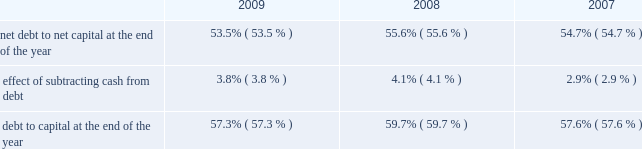Entergy corporation and subsidiaries management's financial discussion and analysis methodology of computing massachusetts state income taxes resulting from legislation passed in the third quarter 2008 , which resulted in an income tax benefit of approximately $ 18.8 million .
These factors were partially offset by : income taxes recorded by entergy power generation , llc , prior to its liquidation , resulting from the redemption payments it received in connection with its investment in entergy nuclear power marketing , llc during the third quarter 2008 , which resulted in an income tax expense of approximately $ 16.1 million ; book and tax differences for utility plant items and state income taxes at the utility operating companies , including the flow-through treatment of the entergy arkansas write-offs discussed above .
The effective income tax rate for 2007 was 30.7% ( 30.7 % ) .
The reduction in the effective income tax rate versus the federal statutory rate of 35% ( 35 % ) in 2007 is primarily due to : a reduction in income tax expense due to a step-up in the tax basis on the indian point 2 non-qualified decommissioning trust fund resulting from restructuring of the trusts , which reduced deferred taxes on the trust fund and reduced current tax expense ; the resolution of tax audit issues involving the 2002-2003 audit cycle ; an adjustment to state income taxes for non-utility nuclear to reflect the effect of a change in the methodology of computing new york state income taxes as required by that state's taxing authority ; book and tax differences related to the allowance for equity funds used during construction ; and the amortization of investment tax credits .
These factors were partially offset by book and tax differences for utility plant items and state income taxes at the utility operating companies .
See note 3 to the financial statements for a reconciliation of the federal statutory rate of 35.0% ( 35.0 % ) to the effective income tax rates , and for additional discussion regarding income taxes .
Liquidity and capital resources this section discusses entergy's capital structure , capital spending plans and other uses of capital , sources of capital , and the cash flow activity presented in the cash flow statement .
Capital structure entergy's capitalization is balanced between equity and debt , as shown in the table .
The decrease in the debt to capital percentage from 2008 to 2009 is primarily the result of an increase in shareholders' equity primarily due to an increase in retained earnings , partially offset by repurchases of common stock , along with a decrease in borrowings under entergy corporation's revolving credit facility .
The increase in the debt to capital percentage from 2007 to 2008 is primarily the result of additional borrowings under entergy corporation's revolving credit facility. .

What is the change in percentage points in debt-to-capital ratio from 2008 to 2009? 
Computations: (57.3 - 59.7)
Answer: -2.4. 